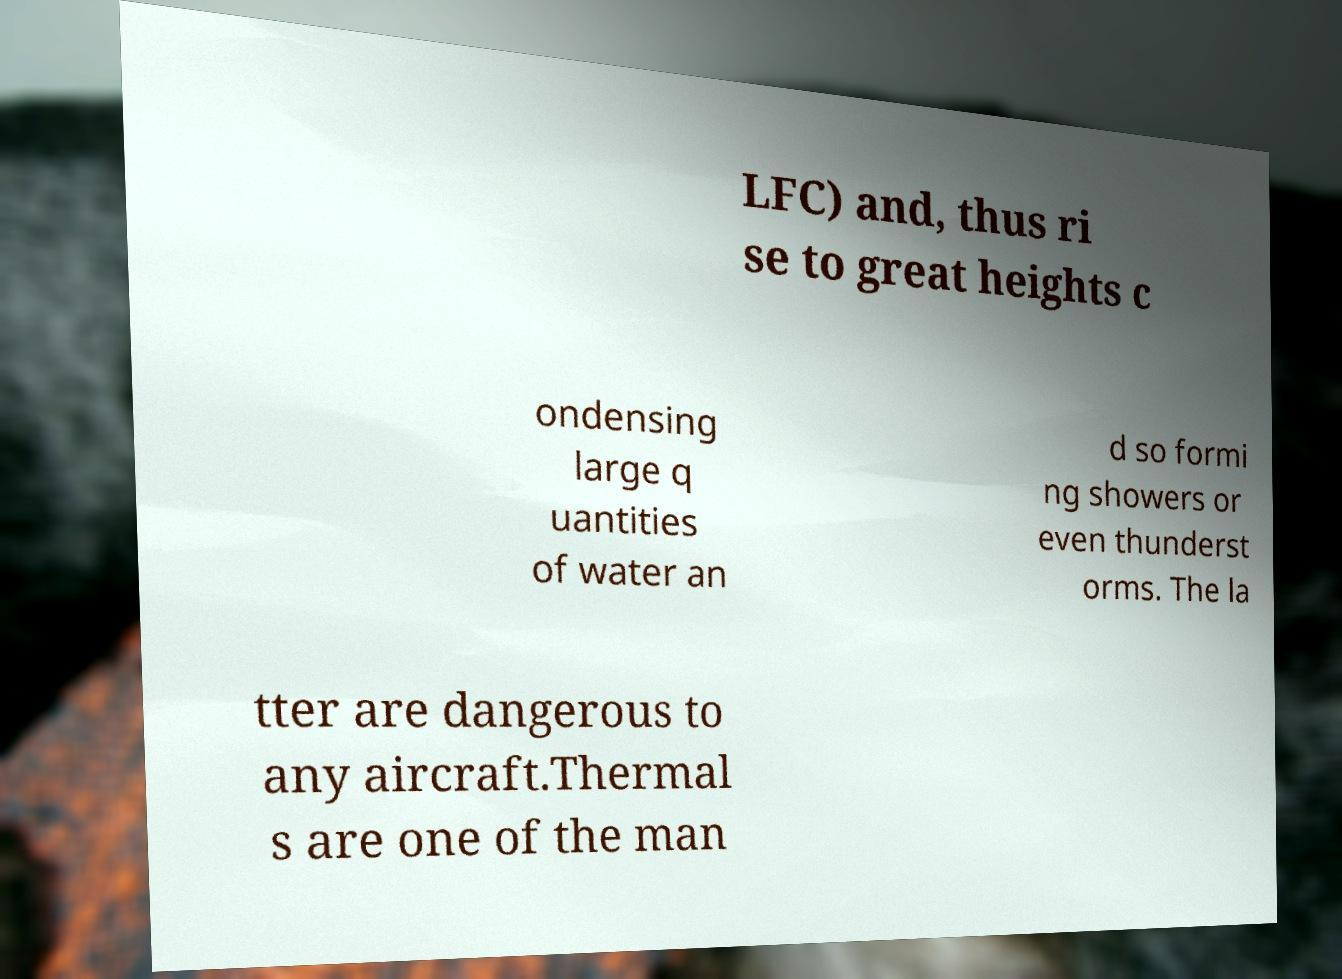Can you read and provide the text displayed in the image?This photo seems to have some interesting text. Can you extract and type it out for me? LFC) and, thus ri se to great heights c ondensing large q uantities of water an d so formi ng showers or even thunderst orms. The la tter are dangerous to any aircraft.Thermal s are one of the man 